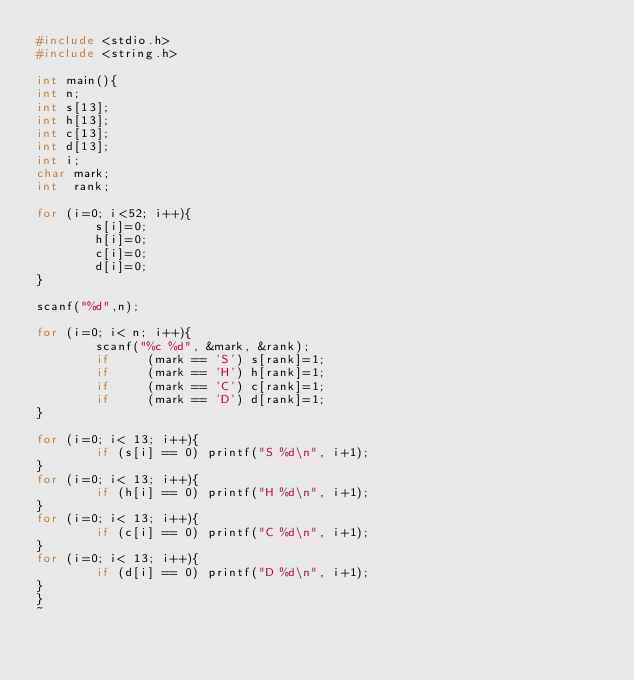Convert code to text. <code><loc_0><loc_0><loc_500><loc_500><_C_>#include <stdio.h>
#include <string.h>

int main(){
int n;
int s[13];
int h[13];
int c[13];
int d[13];
int i;
char mark;
int  rank;

for (i=0; i<52; i++){
        s[i]=0;
        h[i]=0;
        c[i]=0;
        d[i]=0;
}

scanf("%d",n);

for (i=0; i< n; i++){
        scanf("%c %d", &mark, &rank);
        if     (mark == 'S') s[rank]=1;
        if     (mark == 'H') h[rank]=1;
        if     (mark == 'C') c[rank]=1;
        if     (mark == 'D') d[rank]=1;
}

for (i=0; i< 13; i++){
        if (s[i] == 0) printf("S %d\n", i+1);
}
for (i=0; i< 13; i++){
        if (h[i] == 0) printf("H %d\n", i+1);
}
for (i=0; i< 13; i++){
        if (c[i] == 0) printf("C %d\n", i+1);
}
for (i=0; i< 13; i++){
        if (d[i] == 0) printf("D %d\n", i+1);
}
}
~</code> 